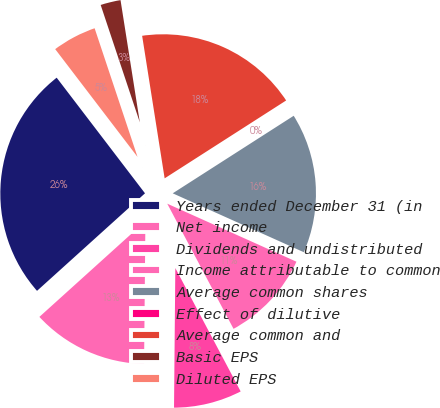Convert chart. <chart><loc_0><loc_0><loc_500><loc_500><pie_chart><fcel>Years ended December 31 (in<fcel>Net income<fcel>Dividends and undistributed<fcel>Income attributable to common<fcel>Average common shares<fcel>Effect of dilutive<fcel>Average common and<fcel>Basic EPS<fcel>Diluted EPS<nl><fcel>26.31%<fcel>13.16%<fcel>7.9%<fcel>10.53%<fcel>15.79%<fcel>0.0%<fcel>18.42%<fcel>2.63%<fcel>5.26%<nl></chart> 